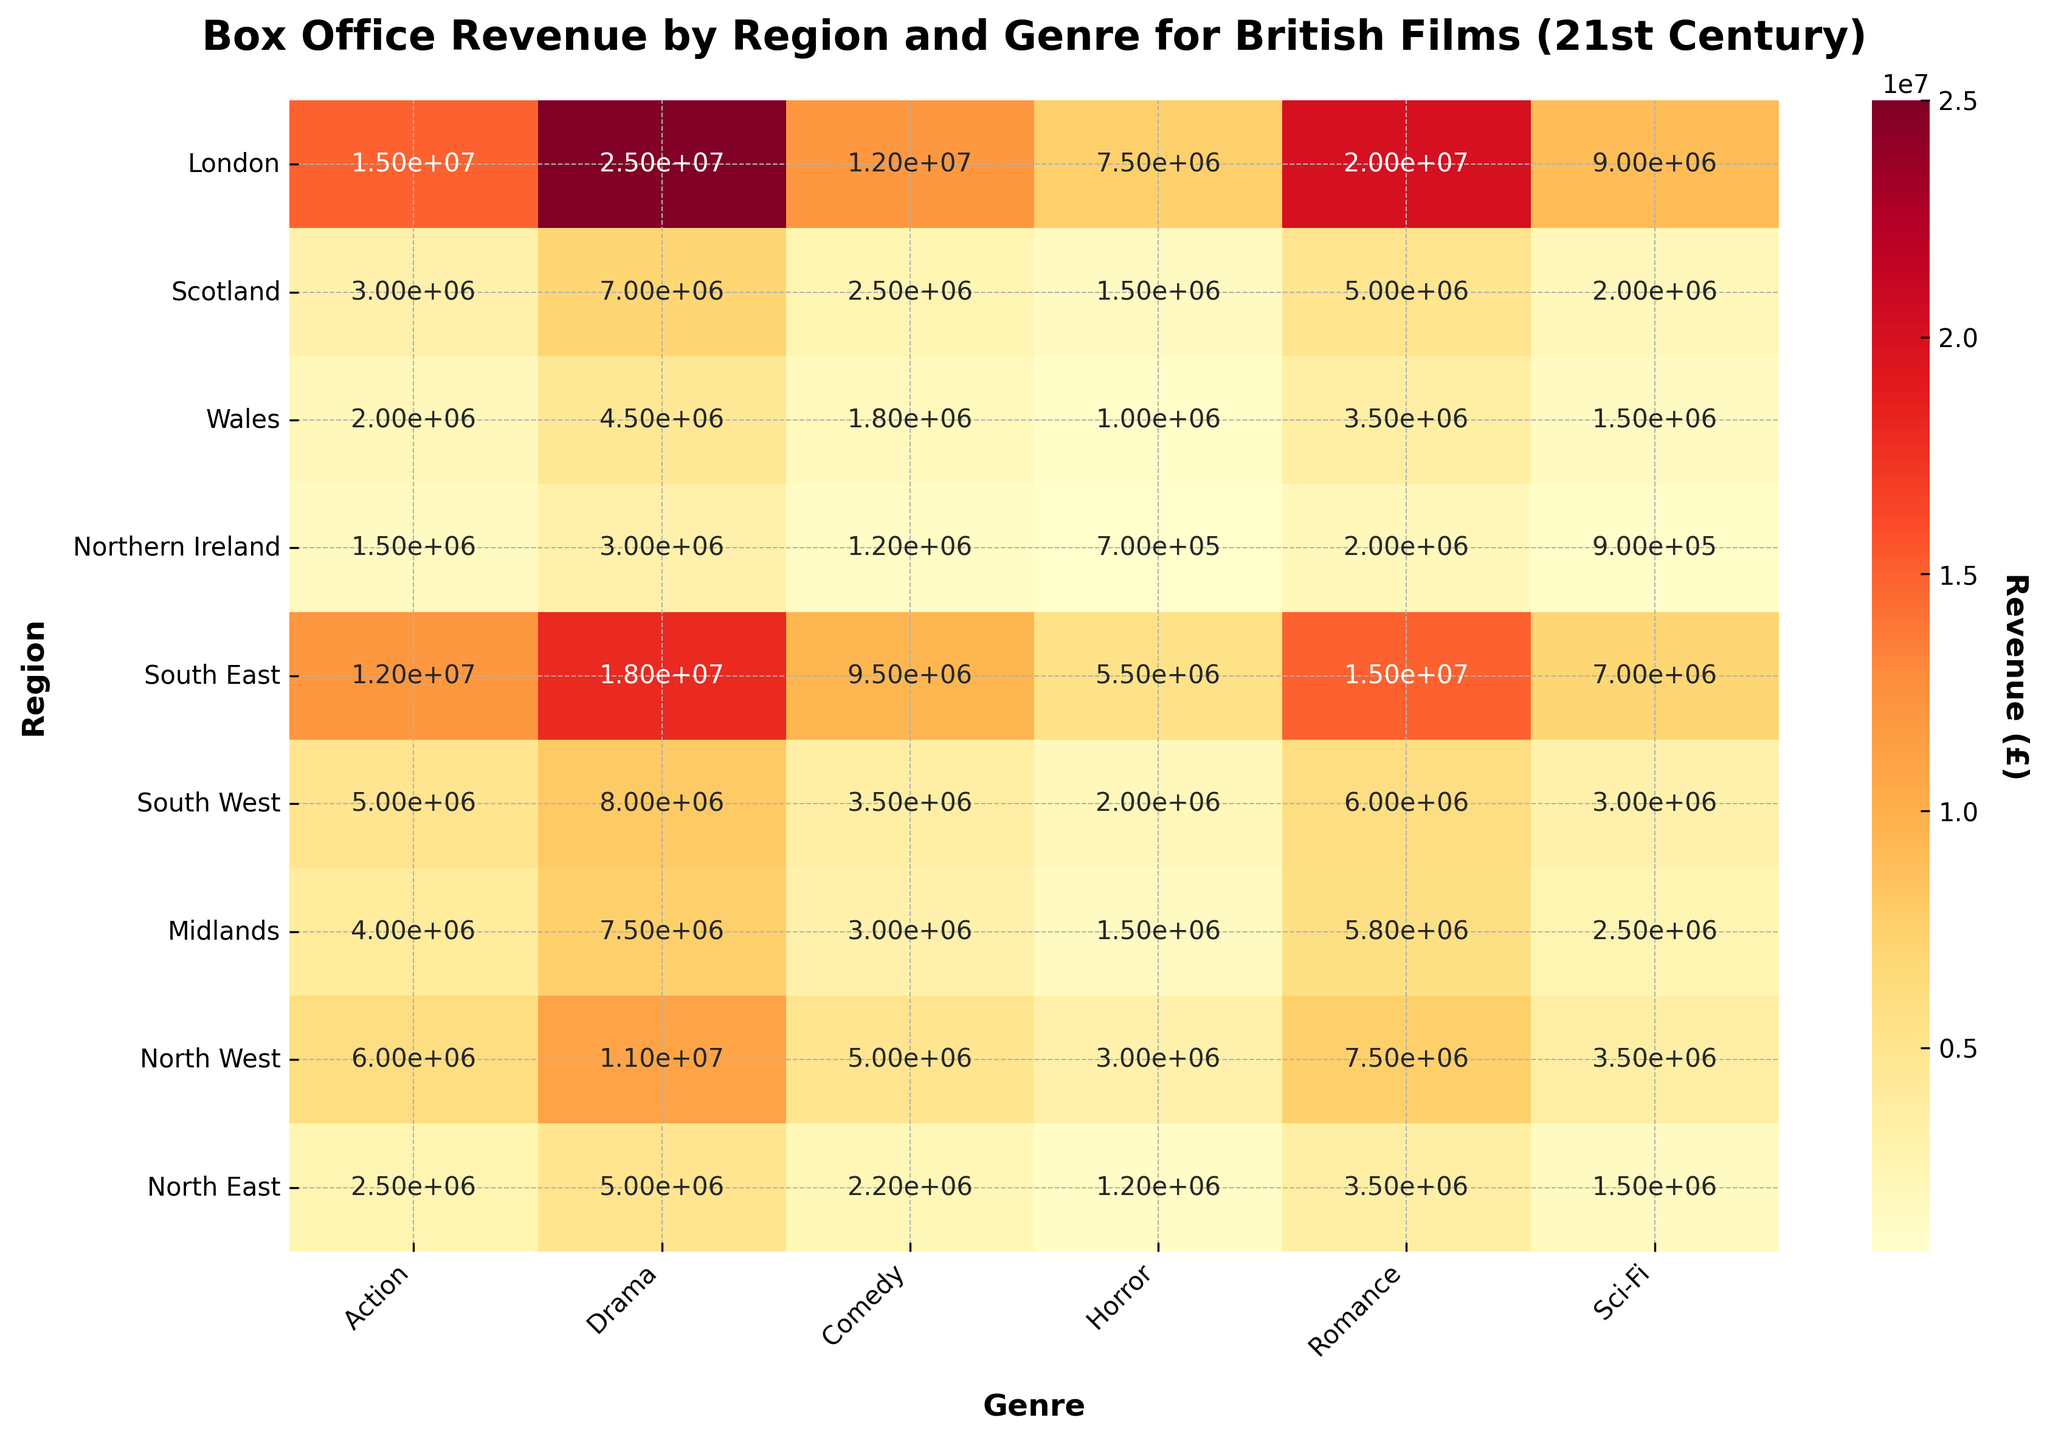what is the total box office revenue for Drama in London? To find the total box office revenue for Drama in London, locate the cell where 'London' row intersects with 'Drama' column, which contains the revenue value.
Answer: £25,000,000 Which region has the highest revenue for Horror films? To determine the region with the highest revenue for Horror, look at the vertical column labeled 'Horror'. Identify the maximum value and then trace it back to the corresponding row/region.
Answer: London What is the average revenue for Comedy films across all regions? Sum the revenue values in the "Comedy" column and then divide by the number of regions (9). The sum is 12,000,000 + 2,500,000 + 1,800,000 + 1,200,000 + 9,500,000 + 3,500,000 + 3,000,000 + 5,000,000 + 2,200,000 = 40,700,000. Dividing by 9 gives 40,700,000 / 9 ≈ 4,522,222.
Answer: ≈ £4,522,222 How does the revenue for Romance films in the South East compare to the North West? Locate the 'South East' row and the 'North West' row, then find the corresponding values under the 'Romance' column. Compare £15,000,000 (South East) to £7,500,000 (North West).
Answer: South East > North West Which genre has the lowest revenue in Wales? Find the 'Wales' row and identify the minimum value among the different genre columns.
Answer: Horror By how much does the revenue for Sci-Fi films in the Midlands exceed that in Northern Ireland? Locate the 'Midlands' row and 'Northern Ireland' row, then find the corresponding values under the 'Sci-Fi' column. Calculate the difference: £2,500,000 (Midlands) - £900,000 (Northern Ireland) = £1,600,000.
Answer: £1,600,000 Compare the revenues of Action and Sci-Fi genres in Scotland. Which is higher? Find 'Scotland' row, and compare the values under 'Action' (£3,000,000) and 'Sci-Fi' (£2,000,000) columns.
Answer: Action What is the total revenue from all genres combined in the North East? Add up all the values in the 'North East' row: £2,500,000 + £5,000,000 + £2,200,000 + £1,200,000 + £3,500,000 + £1,500,000 = £15,900,000.
Answer: £15,900,000 Which three regions have the highest revenue for the Comedy genre? Look at the 'Comedy' column and identify the three highest values, then locate their corresponding regions: £12,000,000 (London), £9,500,000 (South East), and £5,000,000 (North West).
Answer: London, South East, and North West 